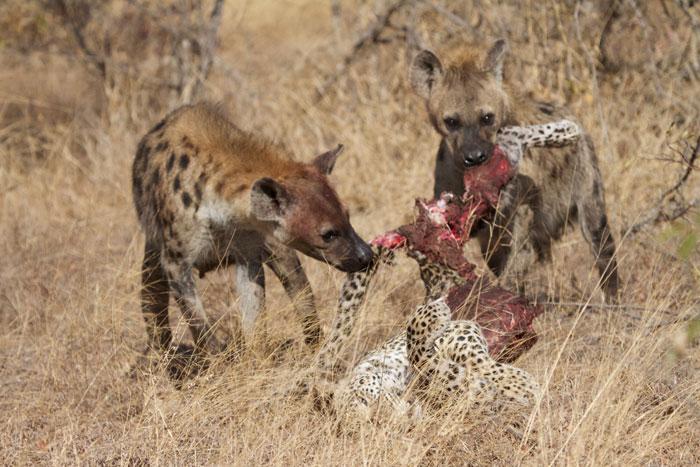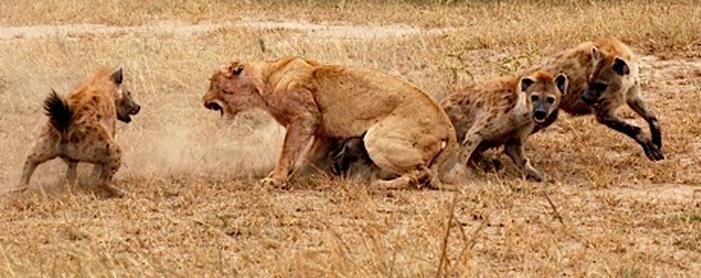The first image is the image on the left, the second image is the image on the right. Examine the images to the left and right. Is the description "An image shows no more than two hyenas standing with the carcass of a leopard-type spotted cat." accurate? Answer yes or no. Yes. The first image is the image on the left, the second image is the image on the right. Evaluate the accuracy of this statement regarding the images: "There's no more than two hyenas in the left image.". Is it true? Answer yes or no. Yes. 